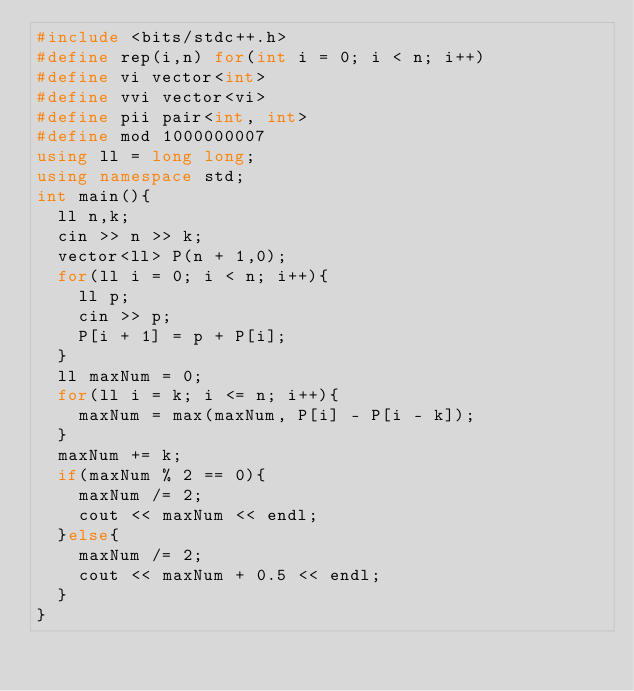Convert code to text. <code><loc_0><loc_0><loc_500><loc_500><_C++_>#include <bits/stdc++.h>
#define rep(i,n) for(int i = 0; i < n; i++)
#define vi vector<int>
#define vvi vector<vi>
#define pii pair<int, int>
#define mod 1000000007
using ll = long long;
using namespace std;
int main(){
  ll n,k;
  cin >> n >> k;
  vector<ll> P(n + 1,0);
  for(ll i = 0; i < n; i++){
    ll p;
    cin >> p;
    P[i + 1] = p + P[i];
  }
  ll maxNum = 0;
  for(ll i = k; i <= n; i++){
    maxNum = max(maxNum, P[i] - P[i - k]);
  }
  maxNum += k;
  if(maxNum % 2 == 0){
    maxNum /= 2;
    cout << maxNum << endl;
  }else{
    maxNum /= 2;
    cout << maxNum + 0.5 << endl;
  }
}</code> 